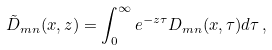Convert formula to latex. <formula><loc_0><loc_0><loc_500><loc_500>\tilde { D } _ { m n } ( x , z ) = \int _ { 0 } ^ { \infty } e ^ { - z \tau } D _ { m n } ( x , \tau ) d \tau \, ,</formula> 